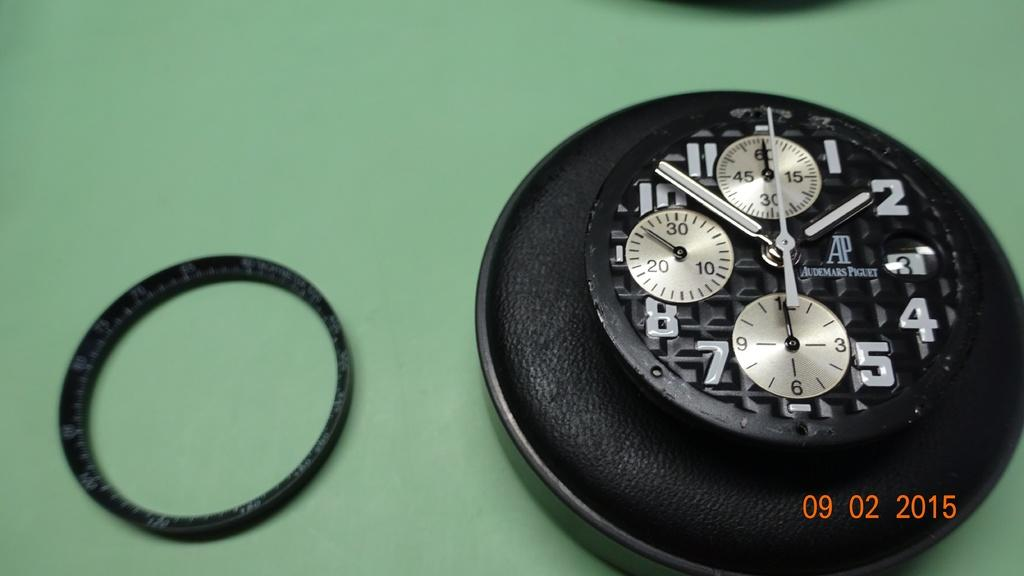<image>
Relay a brief, clear account of the picture shown. A black watch face from Audemars Piguet sits next to a black ring in this photo dated 09/02/2015. 